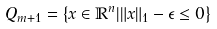<formula> <loc_0><loc_0><loc_500><loc_500>Q _ { m + 1 } = \left \{ x \in \mathbb { R } ^ { n } | \| x \| _ { 1 } - \epsilon \leq 0 \right \}</formula> 